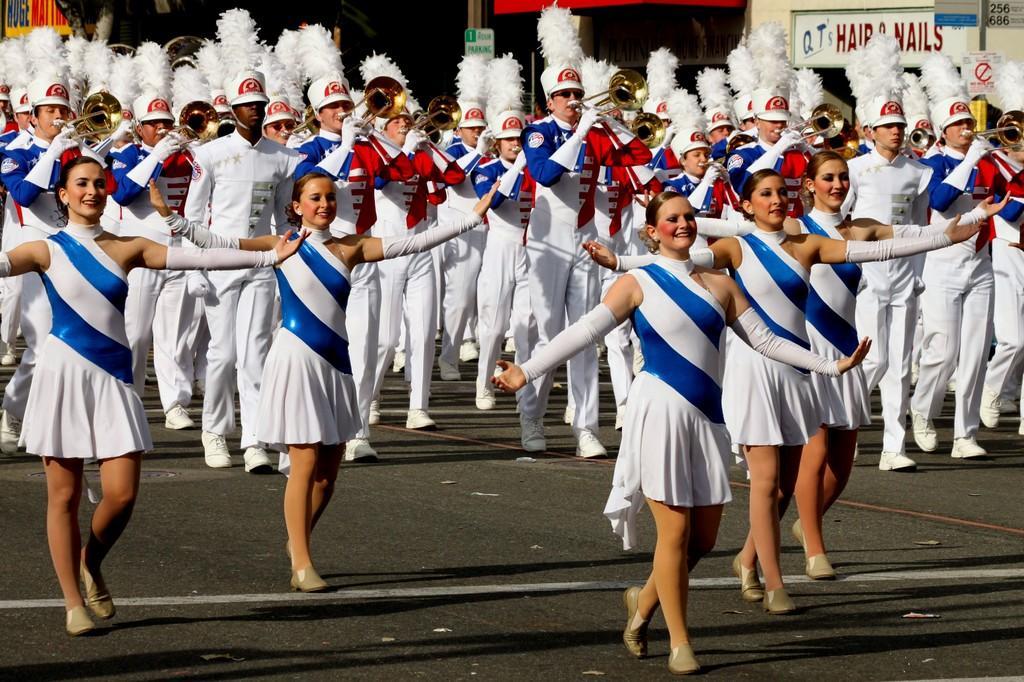Could you give a brief overview of what you see in this image? In the image we can see there are five girls and men, wearing clothes and they are walking. The men are wearing cap, gloves, shoes and they are holding musical instruments in their hands. There is a road and white lines on the road. Here we can see a board and text on it.  